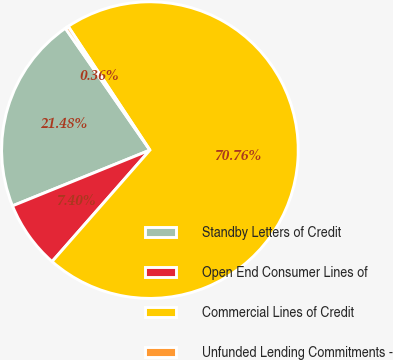<chart> <loc_0><loc_0><loc_500><loc_500><pie_chart><fcel>Standby Letters of Credit<fcel>Open End Consumer Lines of<fcel>Commercial Lines of Credit<fcel>Unfunded Lending Commitments -<nl><fcel>21.48%<fcel>7.4%<fcel>70.76%<fcel>0.36%<nl></chart> 